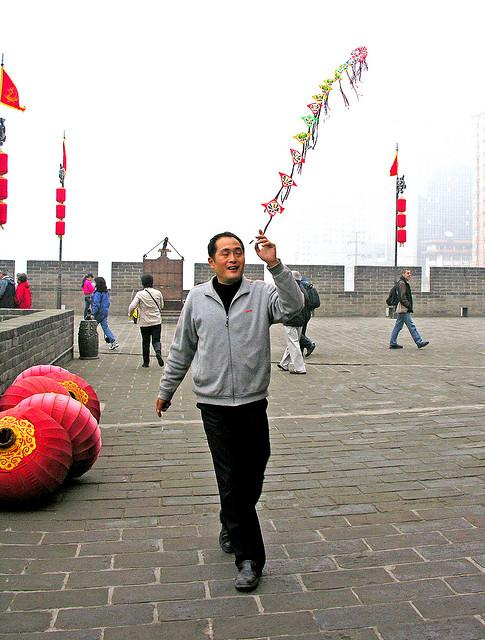The man closest to the right has what kind of pants on?

Choices:
A) jeans
B) khakis
C) shorts
D) tights jeans 